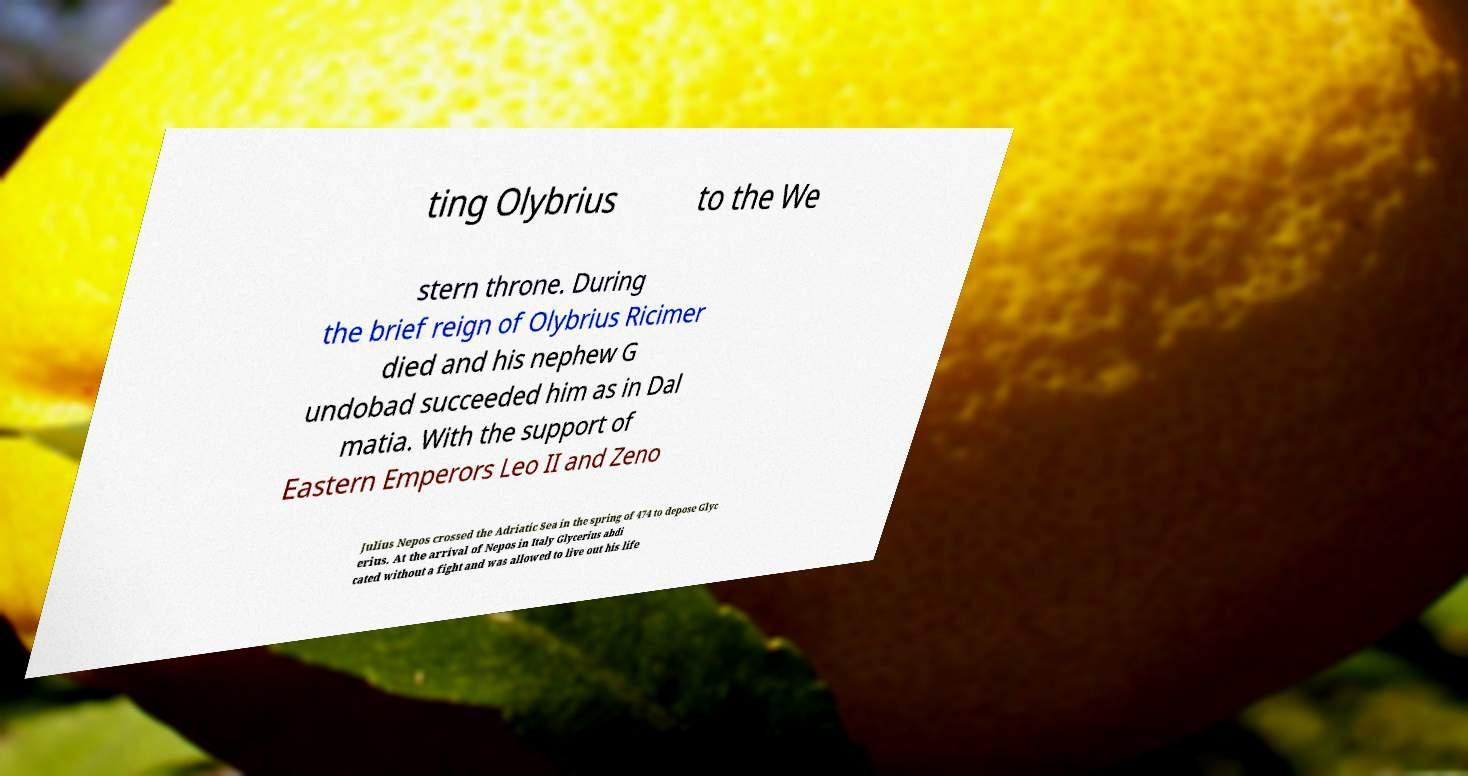There's text embedded in this image that I need extracted. Can you transcribe it verbatim? ting Olybrius to the We stern throne. During the brief reign of Olybrius Ricimer died and his nephew G undobad succeeded him as in Dal matia. With the support of Eastern Emperors Leo II and Zeno Julius Nepos crossed the Adriatic Sea in the spring of 474 to depose Glyc erius. At the arrival of Nepos in Italy Glycerius abdi cated without a fight and was allowed to live out his life 